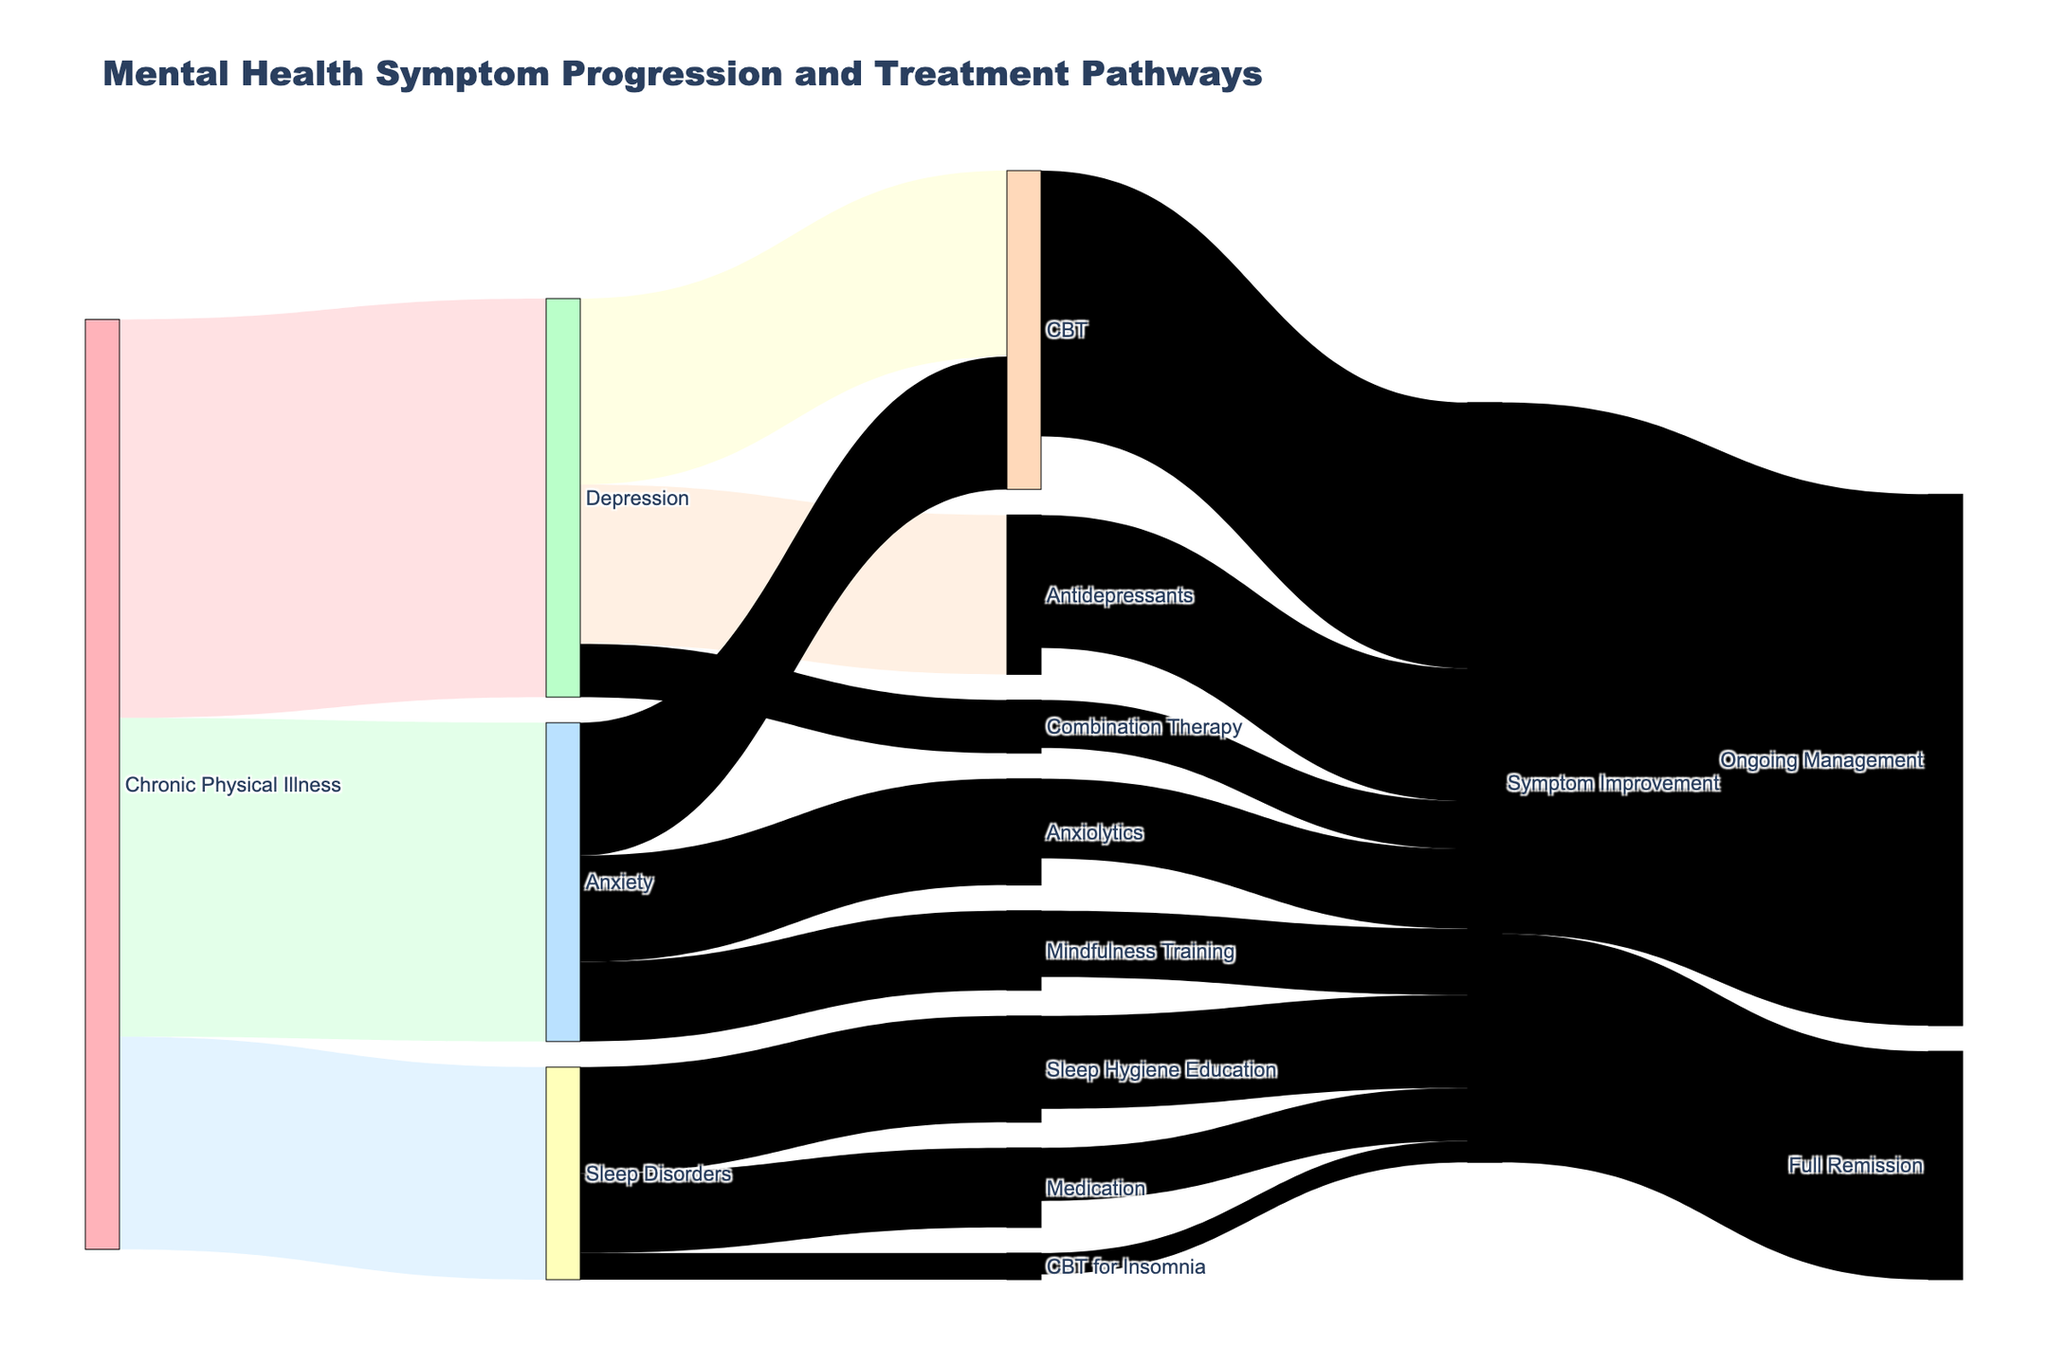What is the most common mental health symptom associated with Chronic Physical Illness? "Depression" is linked to Chronic Physical Illness with the highest value, 150.
Answer: Depression Which treatment for Depression has the highest value? "CBT" for Depression is the treatment with the highest value, 70.
Answer: CBT What is the combined value of patients with Chronic Physical Illness who have Anxiety or Sleep Disorders? Sum the values for Anxiety (120) and Sleep Disorders (80): 120 + 80 = 200.
Answer: 200 How many patients show Symptom Improvement following CBT? The figure shows that "CBT" results in Symptom Improvement for 100 patients.
Answer: 100 Which treatment for Anxiety leads to the best outcome in terms of Symptom Improvement? "CBT" for Anxiety results in the highest Symptom Improvement value, 50.
Answer: CBT How many patients receiving Medication for Sleep Disorders show Symptom Improvement? The value for Medication for Sleep Disorders leading to Symptom Improvement is 20.
Answer: 20 What is the total number of patients who follow any treatment for Depression? Sum the values for all treatments for Depression: CBT (70) + Antidepressants (60) + Combination Therapy (20): 70 + 60 + 20 = 150.
Answer: 150 Which mental health symptom has the least number of patients receiving treatment? "Sleep Disorders" has the least total treatment value: 40 (Sleep Hygiene Education) + 30 (Medication) + 10 (CBT for Insomnia) = 80.
Answer: Sleep Disorders How many patients in total show Symptom Improvement? Sum all values leading to Symptom Improvement from all treatments: 100 (CBT) + 50 (Antidepressants) + 30 (Anxiolytics) + 25 (Mindfulness Training) + 35 (Sleep Hygiene Education) + 20 (Medication) + 8 (CBT for Insomnia) + 18 (Combination Therapy): 286 patients.
Answer: 286 Which outcome has the higher number of patients, Ongoing Management or Full Remission? Ongoing Management has 200 patients, while Full Remission has 86. Ongoing Management is higher.
Answer: Ongoing Management 